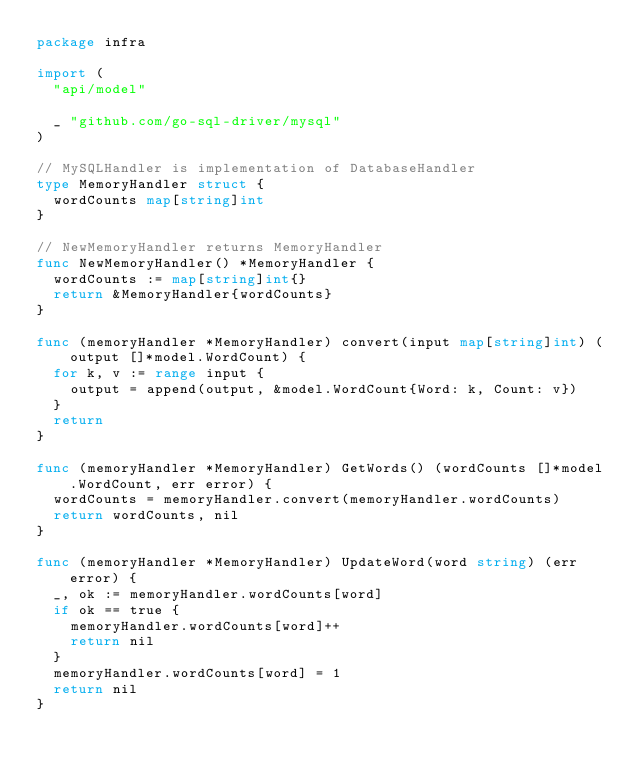<code> <loc_0><loc_0><loc_500><loc_500><_Go_>package infra

import (
	"api/model"

	_ "github.com/go-sql-driver/mysql"
)

// MySQLHandler is implementation of DatabaseHandler
type MemoryHandler struct {
	wordCounts map[string]int
}

// NewMemoryHandler returns MemoryHandler
func NewMemoryHandler() *MemoryHandler {
	wordCounts := map[string]int{}
	return &MemoryHandler{wordCounts}
}

func (memoryHandler *MemoryHandler) convert(input map[string]int) (output []*model.WordCount) {
	for k, v := range input {
		output = append(output, &model.WordCount{Word: k, Count: v})
	}
	return
}

func (memoryHandler *MemoryHandler) GetWords() (wordCounts []*model.WordCount, err error) {
	wordCounts = memoryHandler.convert(memoryHandler.wordCounts)
	return wordCounts, nil
}

func (memoryHandler *MemoryHandler) UpdateWord(word string) (err error) {
	_, ok := memoryHandler.wordCounts[word]
	if ok == true {
		memoryHandler.wordCounts[word]++
		return nil
	}
	memoryHandler.wordCounts[word] = 1
	return nil
}
</code> 